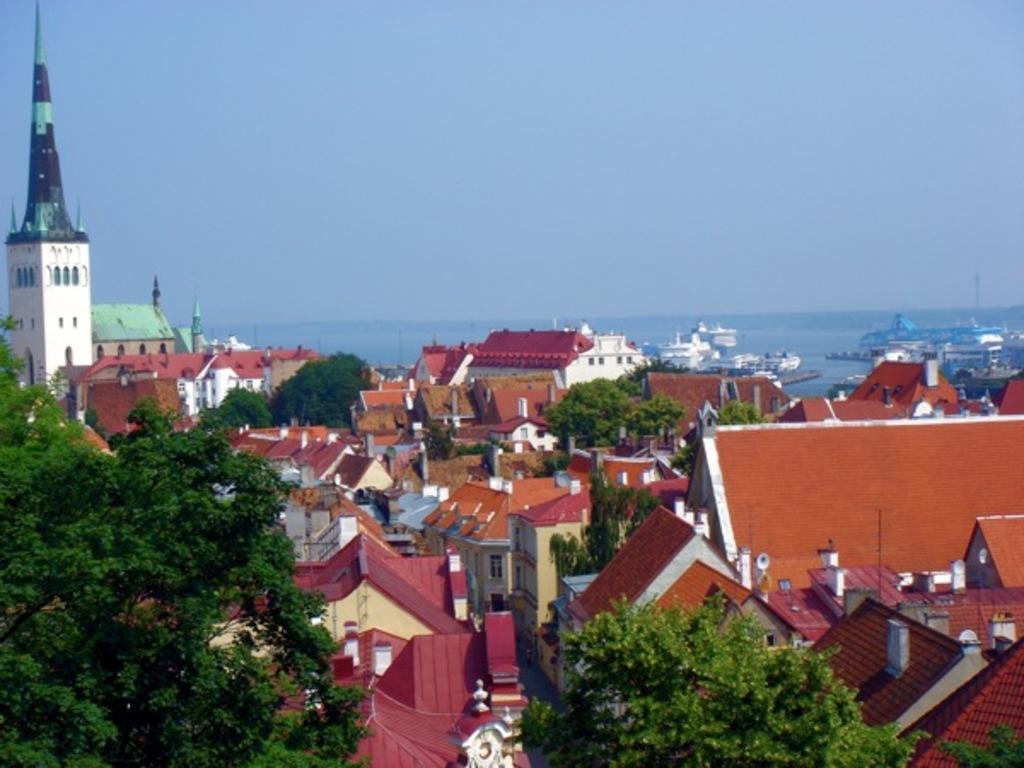How would you summarize this image in a sentence or two? In the background we can see the sky, hills and its blur. In this picture we can see the ships and the water. We can see the poles. This picture is mainly highlighted with the buildings, rooftops. We can see the trees. 